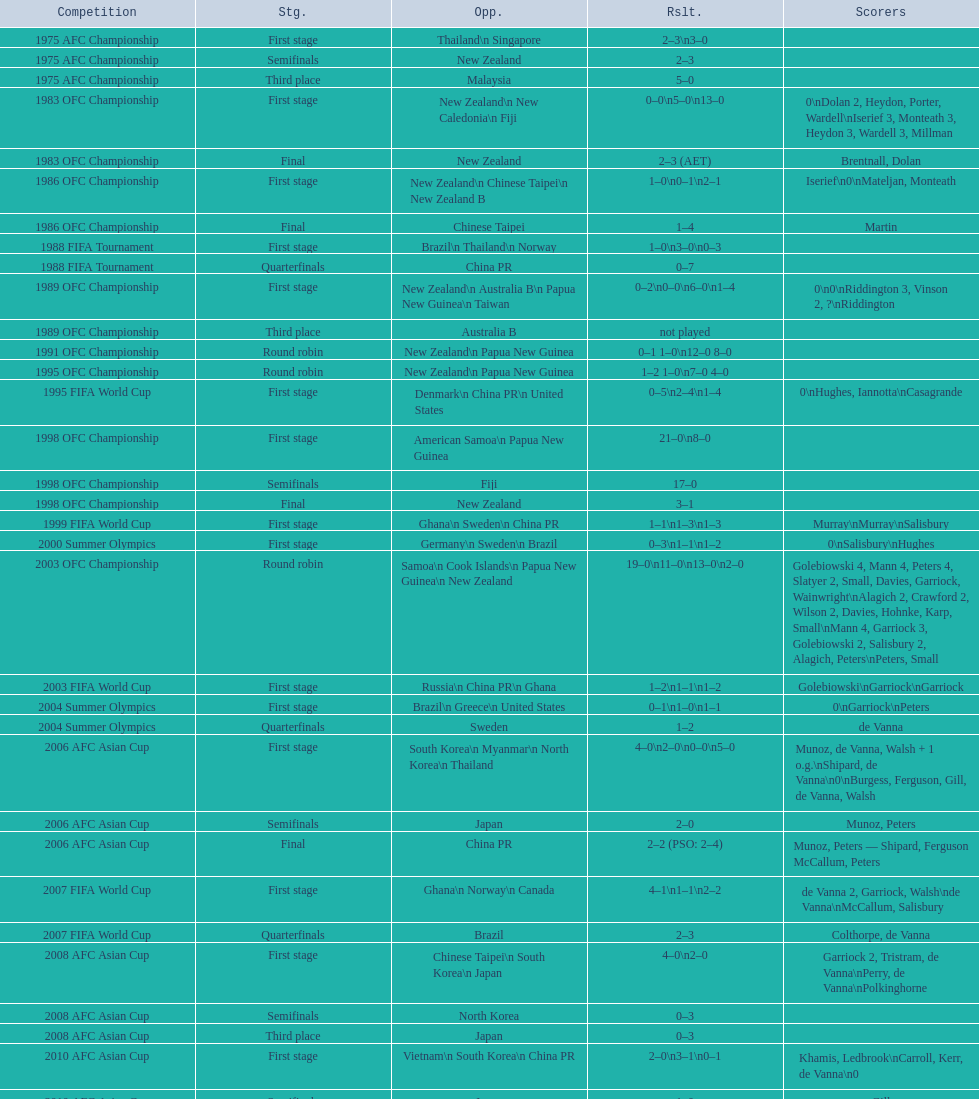What was the number of stages in round robins? 3. Could you parse the entire table? {'header': ['Competition', 'Stg.', 'Opp.', 'Rslt.', 'Scorers'], 'rows': [['1975 AFC Championship', 'First stage', 'Thailand\\n\xa0Singapore', '2–3\\n3–0', ''], ['1975 AFC Championship', 'Semifinals', 'New Zealand', '2–3', ''], ['1975 AFC Championship', 'Third place', 'Malaysia', '5–0', ''], ['1983 OFC Championship', 'First stage', 'New Zealand\\n\xa0New Caledonia\\n\xa0Fiji', '0–0\\n5–0\\n13–0', '0\\nDolan 2, Heydon, Porter, Wardell\\nIserief 3, Monteath 3, Heydon 3, Wardell 3, Millman'], ['1983 OFC Championship', 'Final', 'New Zealand', '2–3 (AET)', 'Brentnall, Dolan'], ['1986 OFC Championship', 'First stage', 'New Zealand\\n\xa0Chinese Taipei\\n New Zealand B', '1–0\\n0–1\\n2–1', 'Iserief\\n0\\nMateljan, Monteath'], ['1986 OFC Championship', 'Final', 'Chinese Taipei', '1–4', 'Martin'], ['1988 FIFA Tournament', 'First stage', 'Brazil\\n\xa0Thailand\\n\xa0Norway', '1–0\\n3–0\\n0–3', ''], ['1988 FIFA Tournament', 'Quarterfinals', 'China PR', '0–7', ''], ['1989 OFC Championship', 'First stage', 'New Zealand\\n Australia B\\n\xa0Papua New Guinea\\n\xa0Taiwan', '0–2\\n0–0\\n6–0\\n1–4', '0\\n0\\nRiddington 3, Vinson 2,\xa0?\\nRiddington'], ['1989 OFC Championship', 'Third place', 'Australia B', 'not played', ''], ['1991 OFC Championship', 'Round robin', 'New Zealand\\n\xa0Papua New Guinea', '0–1 1–0\\n12–0 8–0', ''], ['1995 OFC Championship', 'Round robin', 'New Zealand\\n\xa0Papua New Guinea', '1–2 1–0\\n7–0 4–0', ''], ['1995 FIFA World Cup', 'First stage', 'Denmark\\n\xa0China PR\\n\xa0United States', '0–5\\n2–4\\n1–4', '0\\nHughes, Iannotta\\nCasagrande'], ['1998 OFC Championship', 'First stage', 'American Samoa\\n\xa0Papua New Guinea', '21–0\\n8–0', ''], ['1998 OFC Championship', 'Semifinals', 'Fiji', '17–0', ''], ['1998 OFC Championship', 'Final', 'New Zealand', '3–1', ''], ['1999 FIFA World Cup', 'First stage', 'Ghana\\n\xa0Sweden\\n\xa0China PR', '1–1\\n1–3\\n1–3', 'Murray\\nMurray\\nSalisbury'], ['2000 Summer Olympics', 'First stage', 'Germany\\n\xa0Sweden\\n\xa0Brazil', '0–3\\n1–1\\n1–2', '0\\nSalisbury\\nHughes'], ['2003 OFC Championship', 'Round robin', 'Samoa\\n\xa0Cook Islands\\n\xa0Papua New Guinea\\n\xa0New Zealand', '19–0\\n11–0\\n13–0\\n2–0', 'Golebiowski 4, Mann 4, Peters 4, Slatyer 2, Small, Davies, Garriock, Wainwright\\nAlagich 2, Crawford 2, Wilson 2, Davies, Hohnke, Karp, Small\\nMann 4, Garriock 3, Golebiowski 2, Salisbury 2, Alagich, Peters\\nPeters, Small'], ['2003 FIFA World Cup', 'First stage', 'Russia\\n\xa0China PR\\n\xa0Ghana', '1–2\\n1–1\\n1–2', 'Golebiowski\\nGarriock\\nGarriock'], ['2004 Summer Olympics', 'First stage', 'Brazil\\n\xa0Greece\\n\xa0United States', '0–1\\n1–0\\n1–1', '0\\nGarriock\\nPeters'], ['2004 Summer Olympics', 'Quarterfinals', 'Sweden', '1–2', 'de Vanna'], ['2006 AFC Asian Cup', 'First stage', 'South Korea\\n\xa0Myanmar\\n\xa0North Korea\\n\xa0Thailand', '4–0\\n2–0\\n0–0\\n5–0', 'Munoz, de Vanna, Walsh + 1 o.g.\\nShipard, de Vanna\\n0\\nBurgess, Ferguson, Gill, de Vanna, Walsh'], ['2006 AFC Asian Cup', 'Semifinals', 'Japan', '2–0', 'Munoz, Peters'], ['2006 AFC Asian Cup', 'Final', 'China PR', '2–2 (PSO: 2–4)', 'Munoz, Peters — Shipard, Ferguson McCallum, Peters'], ['2007 FIFA World Cup', 'First stage', 'Ghana\\n\xa0Norway\\n\xa0Canada', '4–1\\n1–1\\n2–2', 'de Vanna 2, Garriock, Walsh\\nde Vanna\\nMcCallum, Salisbury'], ['2007 FIFA World Cup', 'Quarterfinals', 'Brazil', '2–3', 'Colthorpe, de Vanna'], ['2008 AFC Asian Cup', 'First stage', 'Chinese Taipei\\n\xa0South Korea\\n\xa0Japan', '4–0\\n2–0', 'Garriock 2, Tristram, de Vanna\\nPerry, de Vanna\\nPolkinghorne'], ['2008 AFC Asian Cup', 'Semifinals', 'North Korea', '0–3', ''], ['2008 AFC Asian Cup', 'Third place', 'Japan', '0–3', ''], ['2010 AFC Asian Cup', 'First stage', 'Vietnam\\n\xa0South Korea\\n\xa0China PR', '2–0\\n3–1\\n0–1', 'Khamis, Ledbrook\\nCarroll, Kerr, de Vanna\\n0'], ['2010 AFC Asian Cup', 'Semifinals', 'Japan', '1–0', 'Gill'], ['2010 AFC Asian Cup', 'Final', 'North Korea', '1–1 (PSO: 5–4)', 'Kerr — PSO: Shipard, Ledbrook, Gill, Garriock, Simon'], ['2011 FIFA World Cup', 'First stage', 'Brazil\\n\xa0Equatorial Guinea\\n\xa0Norway', '0–1\\n3–2\\n2–1', '0\\nvan Egmond, Khamis, de Vanna\\nSimon 2'], ['2011 FIFA World Cup', 'Quarterfinals', 'Sweden', '1–3', 'Perry'], ['2012 Summer Olympics\\nAFC qualification', 'Final round', 'North Korea\\n\xa0Thailand\\n\xa0Japan\\n\xa0China PR\\n\xa0South Korea', '0–1\\n5–1\\n0–1\\n1–0\\n2–1', '0\\nHeyman 2, Butt, van Egmond, Simon\\n0\\nvan Egmond\\nButt, de Vanna'], ['2014 AFC Asian Cup', 'First stage', 'Japan\\n\xa0Jordan\\n\xa0Vietnam', 'TBD\\nTBD\\nTBD', '']]} 